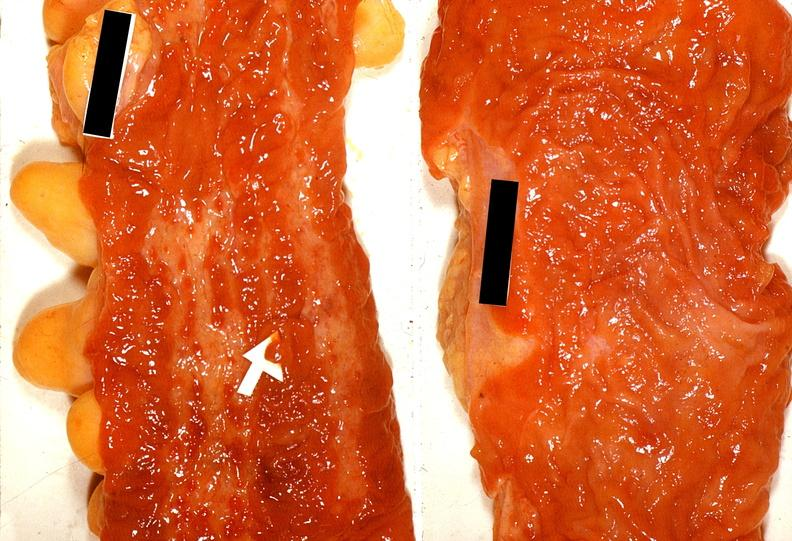s gastrointestinal present?
Answer the question using a single word or phrase. Yes 